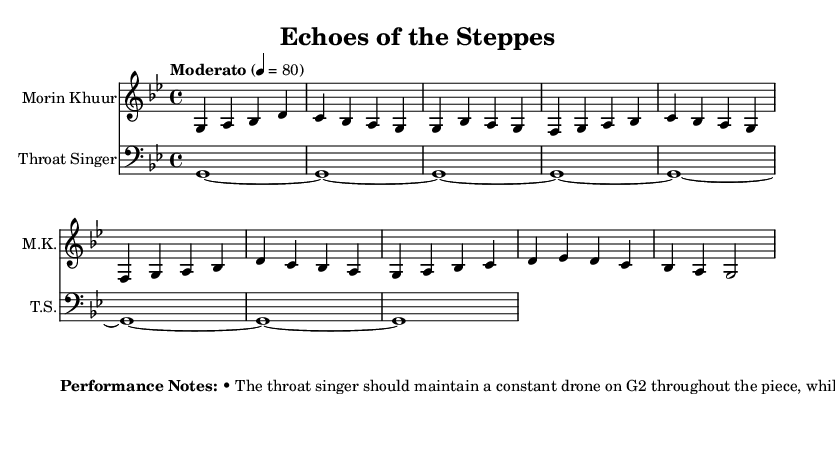What is the time signature of this music? The time signature is indicated at the beginning of the sheet music, and it is shown as "4/4", which means there are four beats in each measure.
Answer: 4/4 What is the key signature of this music? The key signature is displayed at the start of the score. In this case, it is B-flat major or G minor, as indicated by the presence of two flats (B-flat and E-flat).
Answer: G minor What tempo marking is indicated in the score? The tempo marking is found in the header section of the music, stating "Moderato" with a metronome marking of 80 beats per minute, indicating a moderate pace.
Answer: Moderato 80 How many measures are in the introduction section? By counting the measures in the "morin khuur" part labeled as "Introduction", I find that there are 4 measures.
Answer: 4 What is the primary role of the throat singer in this composition? The throat singer's primary role is to maintain a constant drone, specifically on G2, while also emphasizing overtones during choruses as indicated in the performance notes.
Answer: Drone What traditional technique should be used by the morin khuur during the bridge section? The performance notes specify that the morin khuur should apply the 'tseh' technique, which refers to bouncing the bow to create a unique texture.
Answer: Tseh What dynamic contrast is recommended for this piece? The performance notes suggest that softer passages should be played during the verses, while louder and more intense dynamics should be used during the choruses and bridge sections.
Answer: Softer and louder 